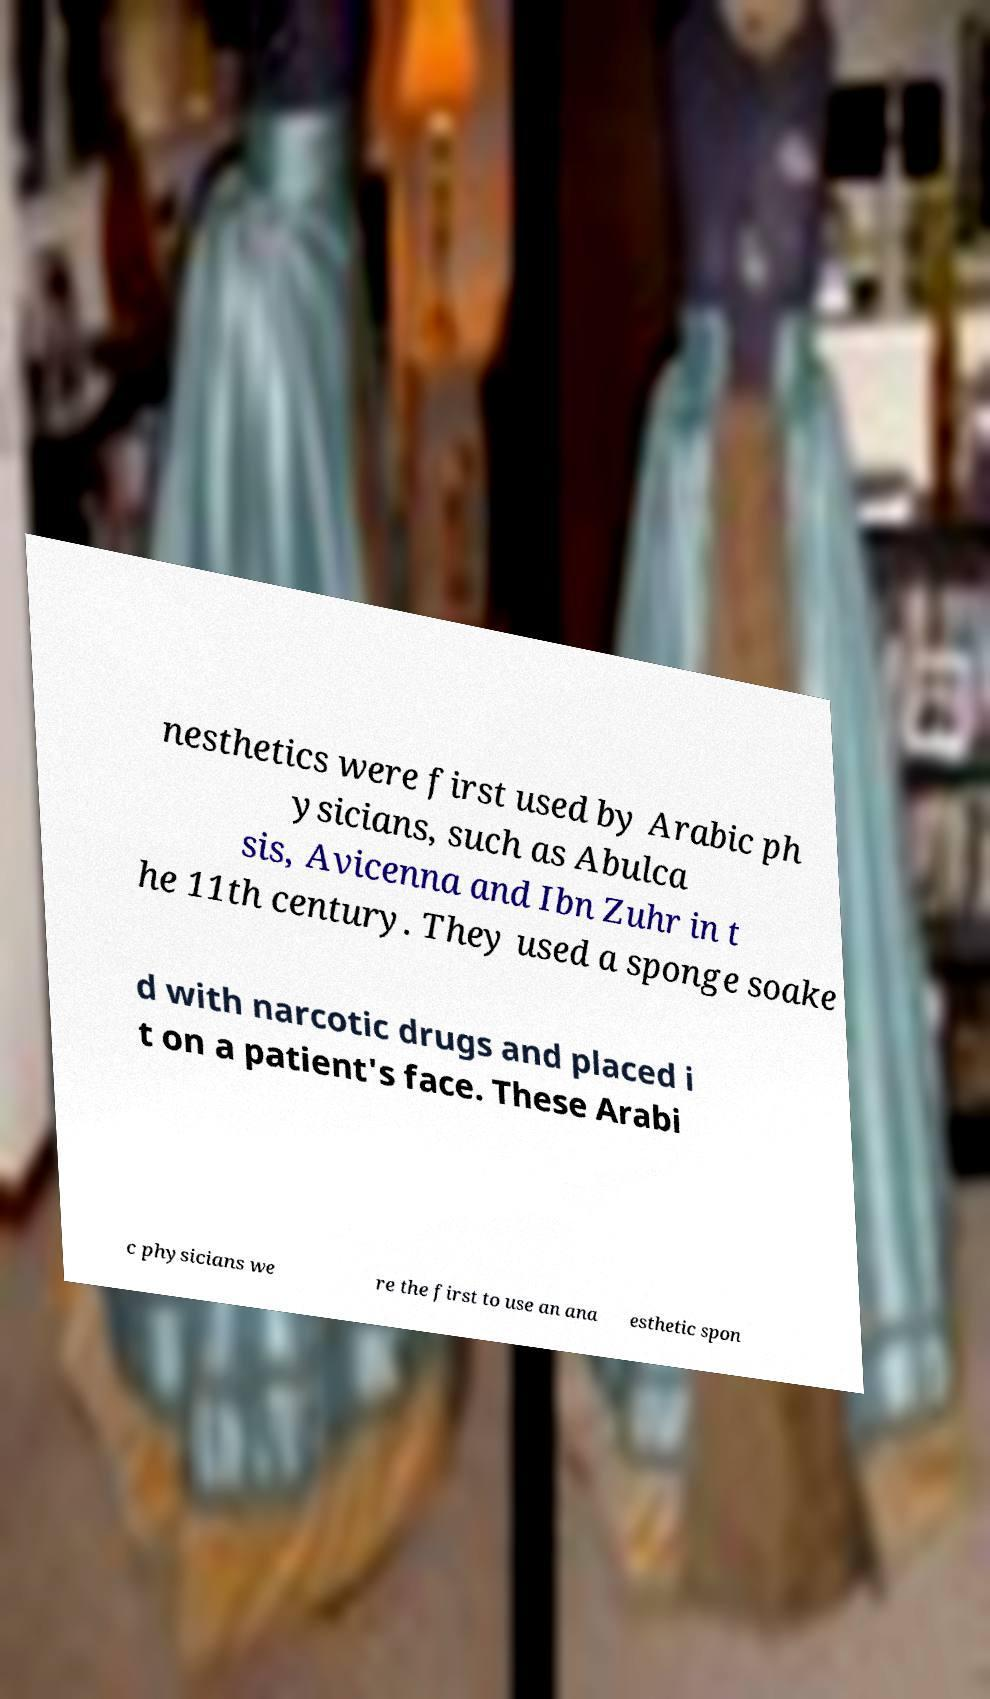There's text embedded in this image that I need extracted. Can you transcribe it verbatim? nesthetics were first used by Arabic ph ysicians, such as Abulca sis, Avicenna and Ibn Zuhr in t he 11th century. They used a sponge soake d with narcotic drugs and placed i t on a patient's face. These Arabi c physicians we re the first to use an ana esthetic spon 